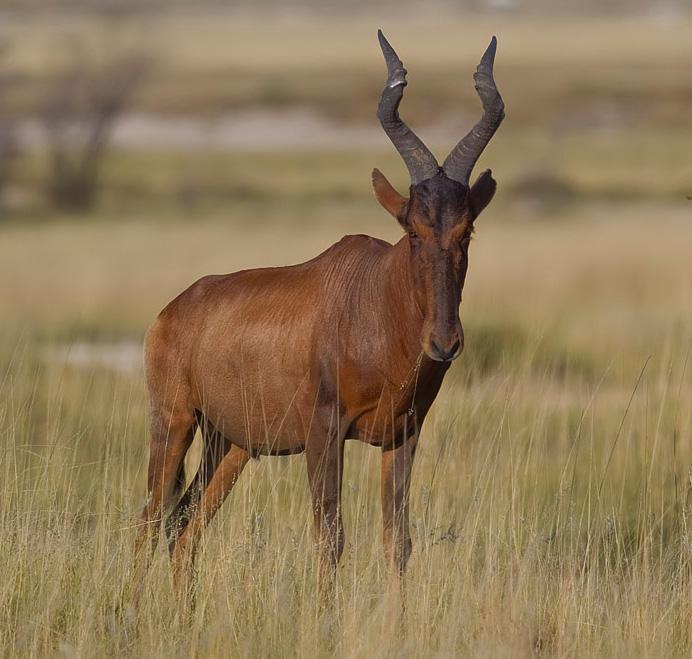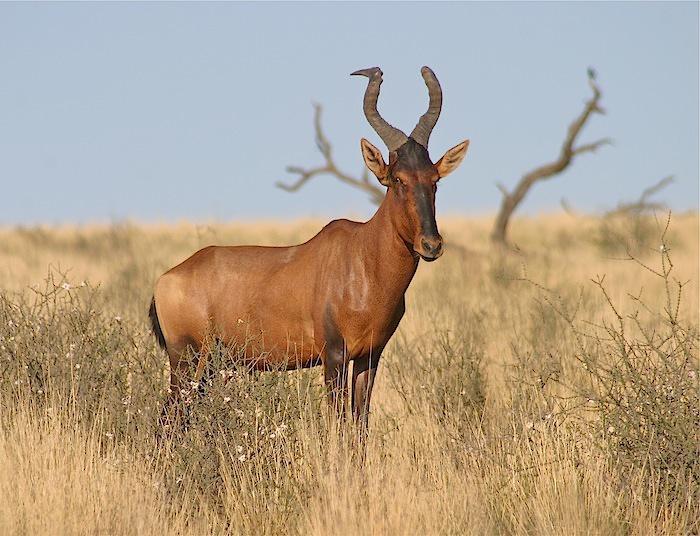The first image is the image on the left, the second image is the image on the right. Considering the images on both sides, is "The animal in the image on the right is lying down." valid? Answer yes or no. No. 